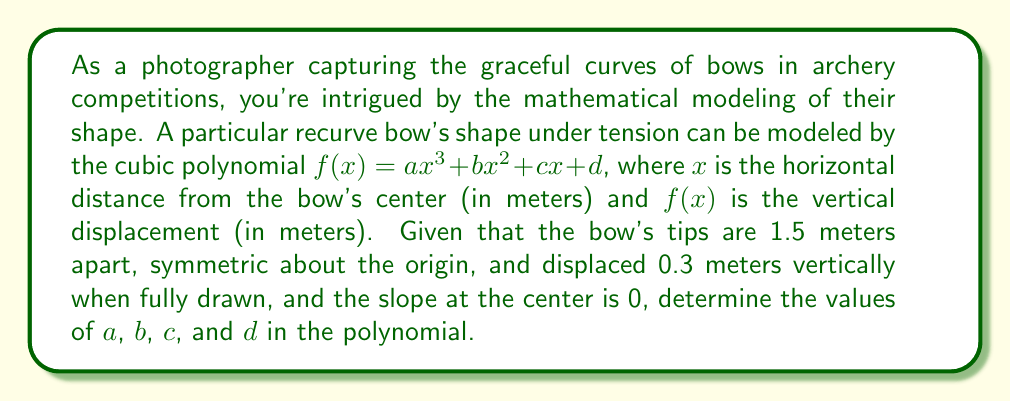Give your solution to this math problem. Let's approach this step-by-step:

1) Given the symmetry about the origin, we can conclude that $b = 0$ and $d = 0$.

2) The polynomial now simplifies to $f(x) = ax^3 + cx$.

3) We have two conditions to use:
   a) At the tip: $f(0.75) = 0.3$
   b) At the center, the slope is 0: $f'(0) = 0$

4) Let's use condition (b) first:
   $f'(x) = 3ax^2 + c$
   $f'(0) = c = 0$

5) So our polynomial further simplifies to $f(x) = ax^3$

6) Now we can use condition (a):
   $f(0.75) = a(0.75)^3 = 0.3$
   $a(0.421875) = 0.3$
   $a = \frac{0.3}{0.421875} = \frac{40}{5.625} = 7.111111...$

7) Therefore, $a \approx 7.111$, $b = 0$, $c = 0$, and $d = 0$.
Answer: $a \approx 7.111$, $b = 0$, $c = 0$, $d = 0$ 